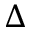Convert formula to latex. <formula><loc_0><loc_0><loc_500><loc_500>\Delta</formula> 